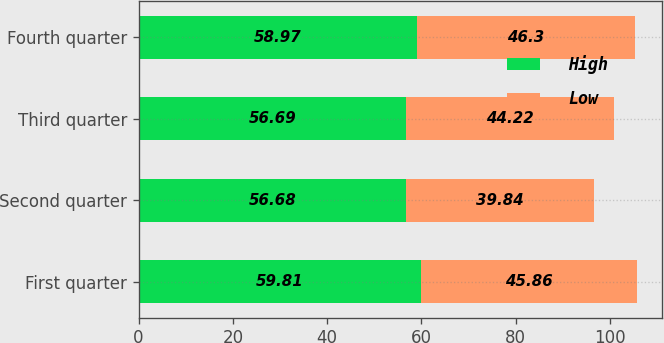Convert chart. <chart><loc_0><loc_0><loc_500><loc_500><stacked_bar_chart><ecel><fcel>First quarter<fcel>Second quarter<fcel>Third quarter<fcel>Fourth quarter<nl><fcel>High<fcel>59.81<fcel>56.68<fcel>56.69<fcel>58.97<nl><fcel>Low<fcel>45.86<fcel>39.84<fcel>44.22<fcel>46.3<nl></chart> 